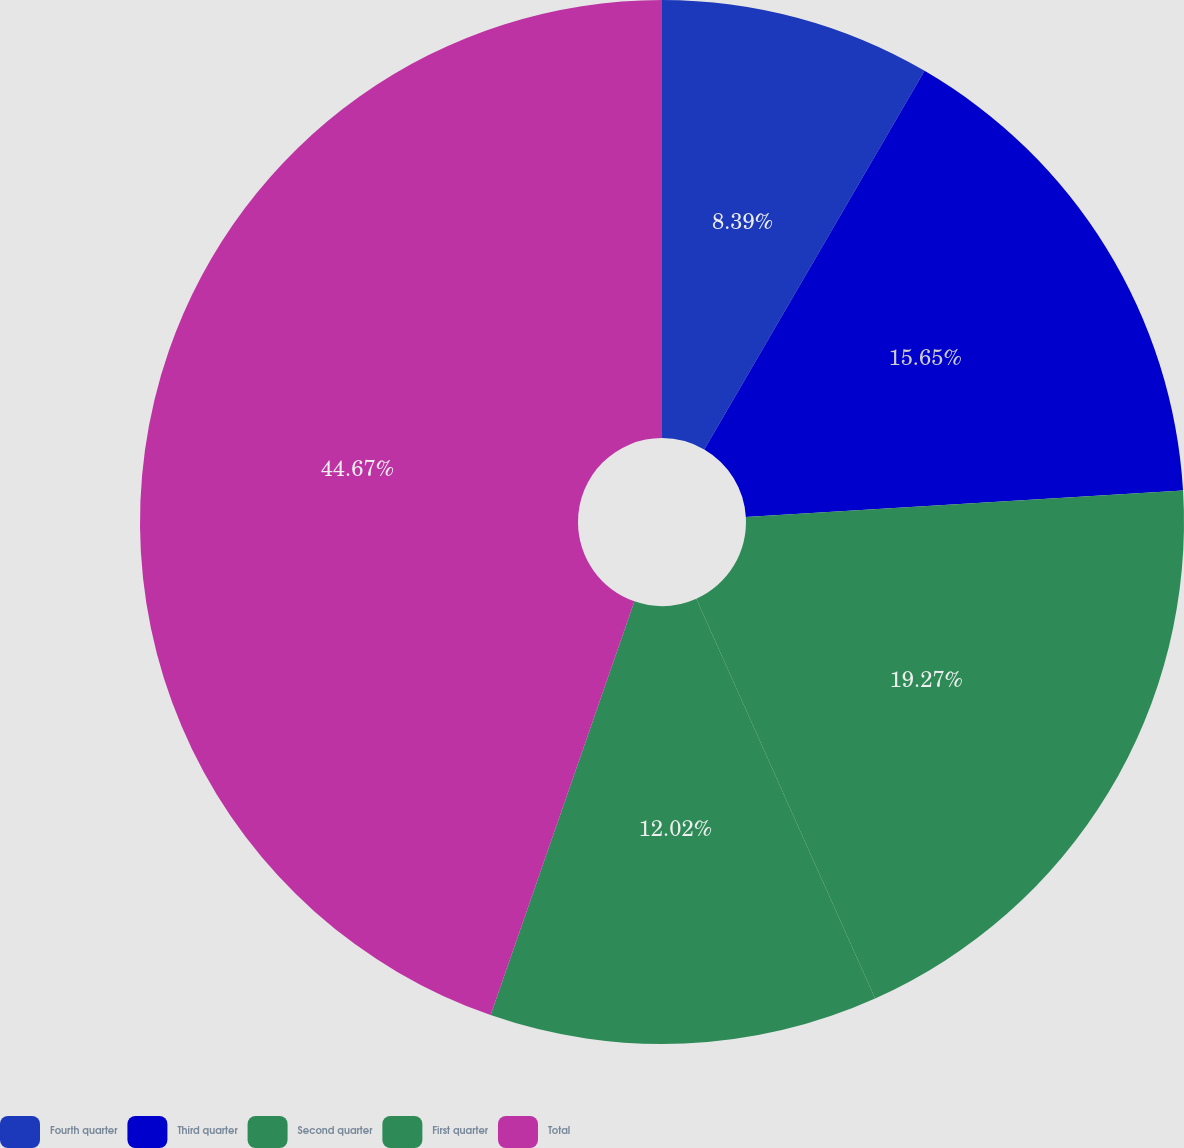<chart> <loc_0><loc_0><loc_500><loc_500><pie_chart><fcel>Fourth quarter<fcel>Third quarter<fcel>Second quarter<fcel>First quarter<fcel>Total<nl><fcel>8.39%<fcel>15.65%<fcel>19.27%<fcel>12.02%<fcel>44.68%<nl></chart> 